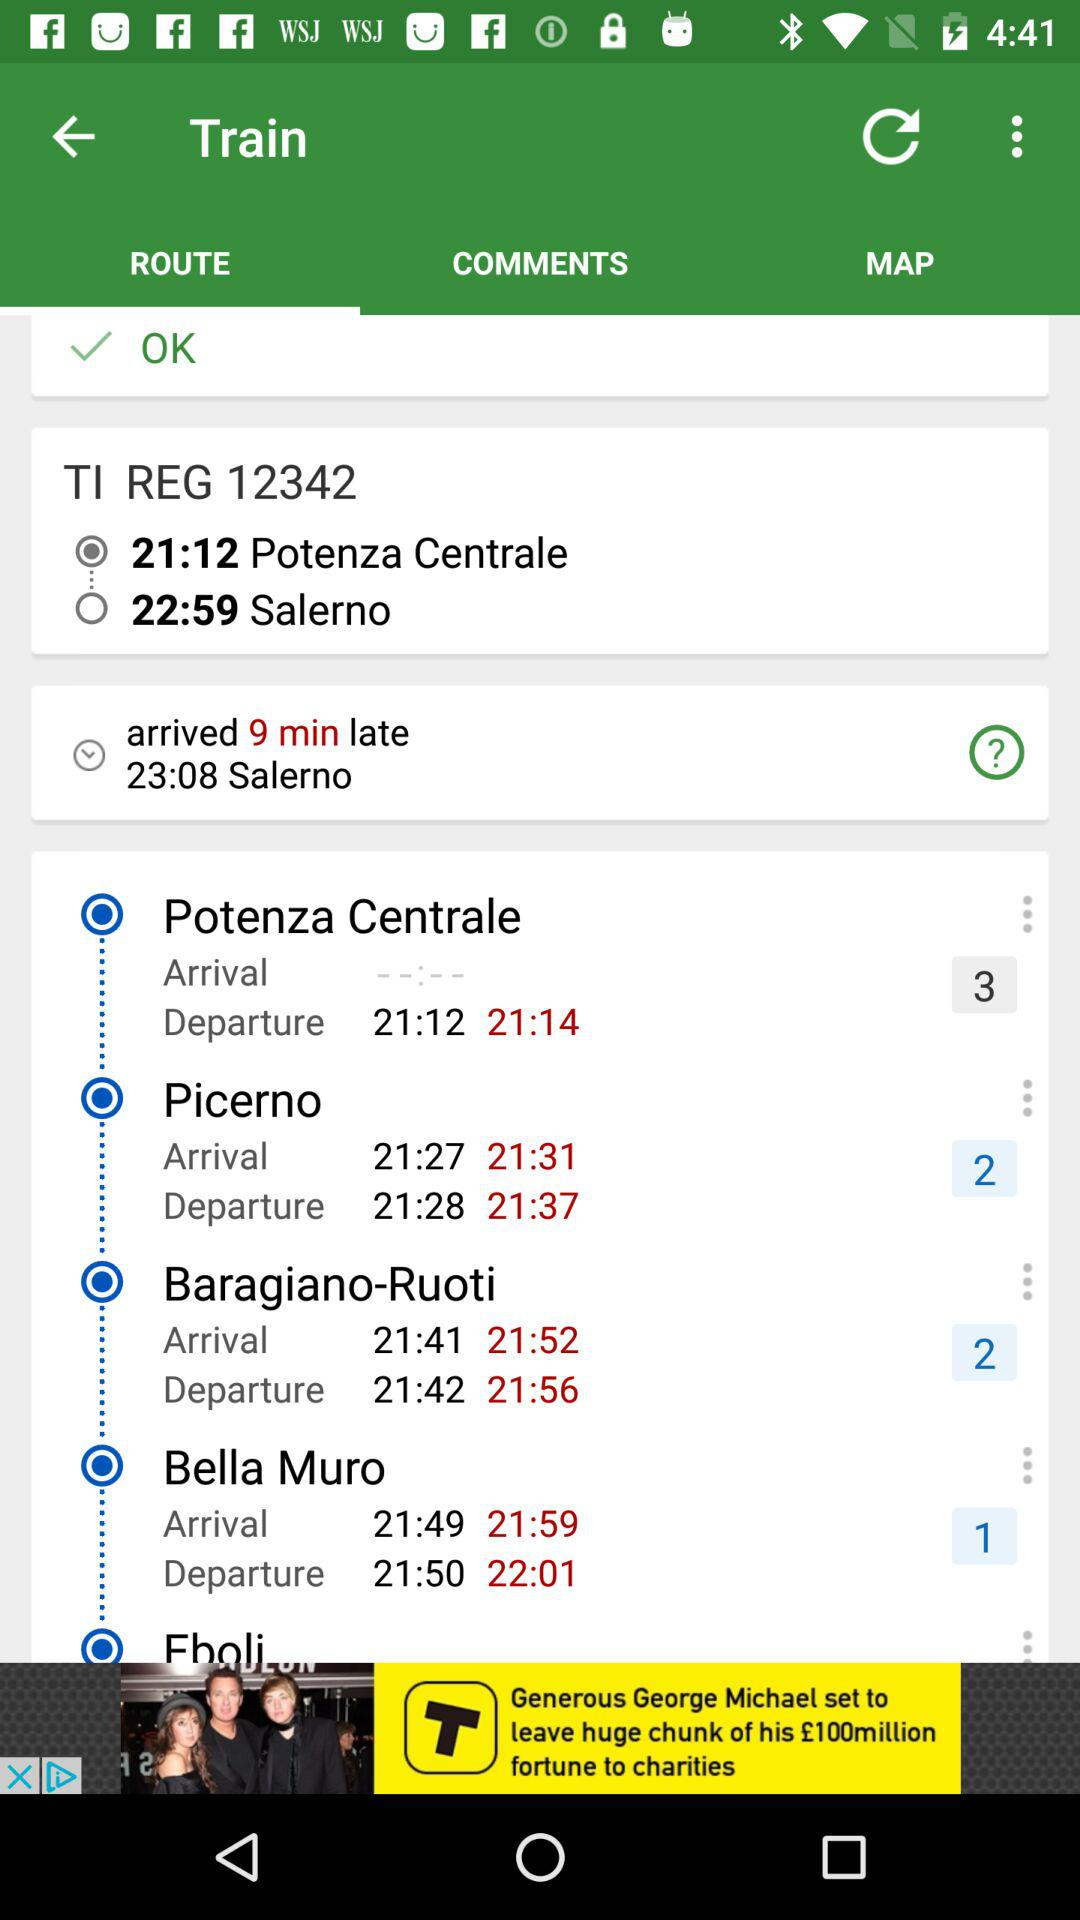Where is the train headed? The train is headed to Salerno. 